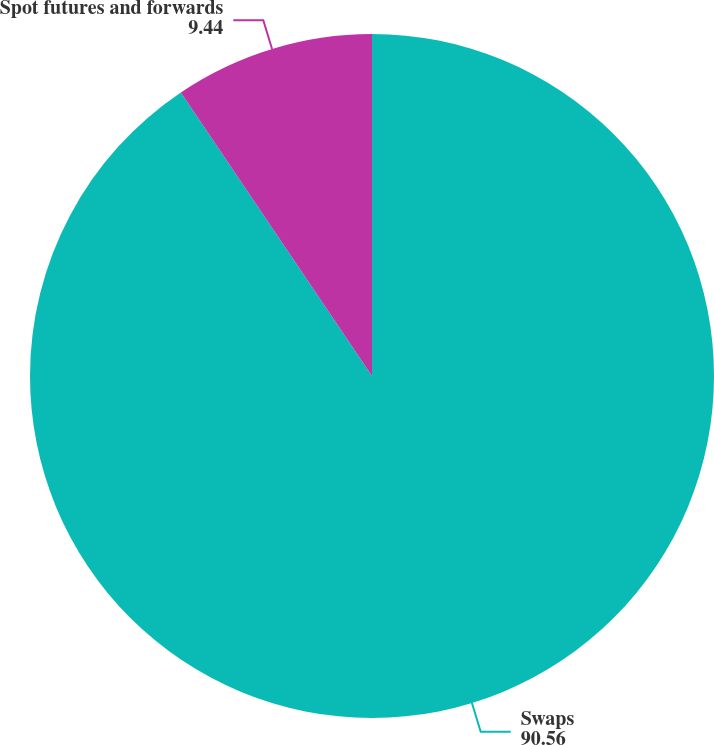<chart> <loc_0><loc_0><loc_500><loc_500><pie_chart><fcel>Swaps<fcel>Spot futures and forwards<nl><fcel>90.56%<fcel>9.44%<nl></chart> 